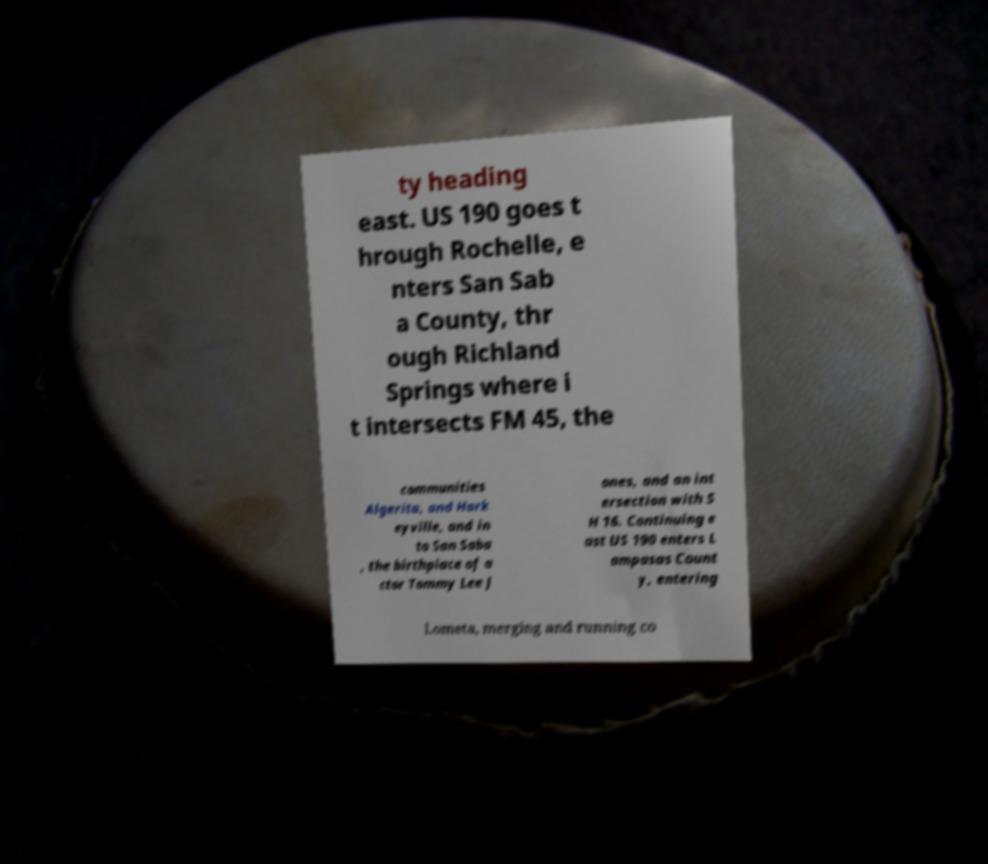I need the written content from this picture converted into text. Can you do that? ty heading east. US 190 goes t hrough Rochelle, e nters San Sab a County, thr ough Richland Springs where i t intersects FM 45, the communities Algerita, and Hark eyville, and in to San Saba , the birthplace of a ctor Tommy Lee J ones, and an int ersection with S H 16. Continuing e ast US 190 enters L ampasas Count y, entering Lometa, merging and running co 